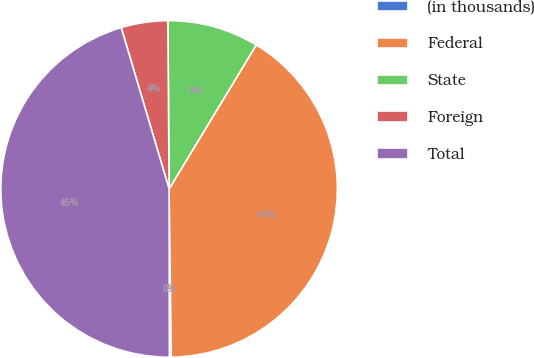<chart> <loc_0><loc_0><loc_500><loc_500><pie_chart><fcel>(in thousands)<fcel>Federal<fcel>State<fcel>Foreign<fcel>Total<nl><fcel>0.18%<fcel>41.13%<fcel>8.78%<fcel>4.48%<fcel>45.43%<nl></chart> 